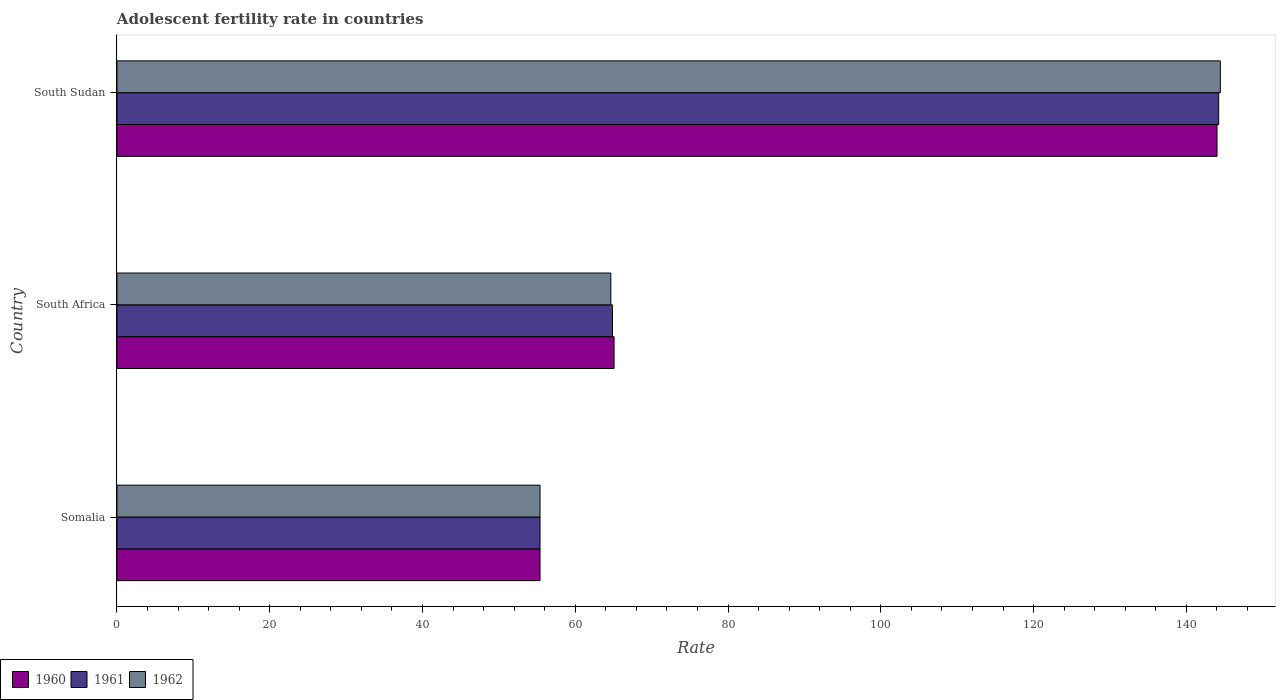How many different coloured bars are there?
Provide a short and direct response. 3. How many groups of bars are there?
Give a very brief answer. 3. Are the number of bars per tick equal to the number of legend labels?
Offer a terse response. Yes. Are the number of bars on each tick of the Y-axis equal?
Provide a succinct answer. Yes. How many bars are there on the 1st tick from the top?
Keep it short and to the point. 3. What is the label of the 1st group of bars from the top?
Offer a very short reply. South Sudan. What is the adolescent fertility rate in 1960 in South Sudan?
Give a very brief answer. 144.02. Across all countries, what is the maximum adolescent fertility rate in 1960?
Provide a succinct answer. 144.02. Across all countries, what is the minimum adolescent fertility rate in 1960?
Your answer should be compact. 55.39. In which country was the adolescent fertility rate in 1961 maximum?
Give a very brief answer. South Sudan. In which country was the adolescent fertility rate in 1961 minimum?
Ensure brevity in your answer.  Somalia. What is the total adolescent fertility rate in 1961 in the graph?
Give a very brief answer. 264.5. What is the difference between the adolescent fertility rate in 1960 in Somalia and that in South Africa?
Provide a short and direct response. -9.7. What is the difference between the adolescent fertility rate in 1960 in South Africa and the adolescent fertility rate in 1961 in South Sudan?
Provide a succinct answer. -79.15. What is the average adolescent fertility rate in 1961 per country?
Make the answer very short. 88.17. What is the difference between the adolescent fertility rate in 1960 and adolescent fertility rate in 1961 in Somalia?
Your response must be concise. 0. In how many countries, is the adolescent fertility rate in 1962 greater than 4 ?
Ensure brevity in your answer.  3. What is the ratio of the adolescent fertility rate in 1961 in Somalia to that in South Africa?
Your response must be concise. 0.85. Is the adolescent fertility rate in 1960 in Somalia less than that in South Sudan?
Ensure brevity in your answer.  Yes. What is the difference between the highest and the second highest adolescent fertility rate in 1961?
Your response must be concise. 79.36. What is the difference between the highest and the lowest adolescent fertility rate in 1962?
Keep it short and to the point. 89.06. Is the sum of the adolescent fertility rate in 1962 in Somalia and South Sudan greater than the maximum adolescent fertility rate in 1961 across all countries?
Offer a very short reply. Yes. How many countries are there in the graph?
Offer a terse response. 3. Are the values on the major ticks of X-axis written in scientific E-notation?
Offer a terse response. No. Does the graph contain grids?
Your answer should be very brief. No. What is the title of the graph?
Provide a short and direct response. Adolescent fertility rate in countries. What is the label or title of the X-axis?
Your answer should be compact. Rate. What is the label or title of the Y-axis?
Ensure brevity in your answer.  Country. What is the Rate of 1960 in Somalia?
Keep it short and to the point. 55.39. What is the Rate of 1961 in Somalia?
Make the answer very short. 55.39. What is the Rate of 1962 in Somalia?
Keep it short and to the point. 55.39. What is the Rate in 1960 in South Africa?
Provide a short and direct response. 65.08. What is the Rate in 1961 in South Africa?
Make the answer very short. 64.87. What is the Rate of 1962 in South Africa?
Make the answer very short. 64.66. What is the Rate in 1960 in South Sudan?
Your answer should be compact. 144.02. What is the Rate in 1961 in South Sudan?
Ensure brevity in your answer.  144.24. What is the Rate of 1962 in South Sudan?
Your answer should be very brief. 144.45. Across all countries, what is the maximum Rate of 1960?
Give a very brief answer. 144.02. Across all countries, what is the maximum Rate in 1961?
Your answer should be compact. 144.24. Across all countries, what is the maximum Rate in 1962?
Offer a very short reply. 144.45. Across all countries, what is the minimum Rate of 1960?
Offer a very short reply. 55.39. Across all countries, what is the minimum Rate in 1961?
Your response must be concise. 55.39. Across all countries, what is the minimum Rate of 1962?
Provide a short and direct response. 55.39. What is the total Rate of 1960 in the graph?
Make the answer very short. 264.5. What is the total Rate of 1961 in the graph?
Ensure brevity in your answer.  264.5. What is the total Rate of 1962 in the graph?
Your response must be concise. 264.5. What is the difference between the Rate of 1960 in Somalia and that in South Africa?
Your response must be concise. -9.7. What is the difference between the Rate in 1961 in Somalia and that in South Africa?
Provide a succinct answer. -9.48. What is the difference between the Rate of 1962 in Somalia and that in South Africa?
Offer a terse response. -9.27. What is the difference between the Rate of 1960 in Somalia and that in South Sudan?
Give a very brief answer. -88.63. What is the difference between the Rate in 1961 in Somalia and that in South Sudan?
Make the answer very short. -88.85. What is the difference between the Rate in 1962 in Somalia and that in South Sudan?
Provide a succinct answer. -89.06. What is the difference between the Rate in 1960 in South Africa and that in South Sudan?
Make the answer very short. -78.94. What is the difference between the Rate in 1961 in South Africa and that in South Sudan?
Keep it short and to the point. -79.36. What is the difference between the Rate of 1962 in South Africa and that in South Sudan?
Your response must be concise. -79.79. What is the difference between the Rate in 1960 in Somalia and the Rate in 1961 in South Africa?
Your answer should be compact. -9.48. What is the difference between the Rate in 1960 in Somalia and the Rate in 1962 in South Africa?
Provide a short and direct response. -9.27. What is the difference between the Rate in 1961 in Somalia and the Rate in 1962 in South Africa?
Ensure brevity in your answer.  -9.27. What is the difference between the Rate of 1960 in Somalia and the Rate of 1961 in South Sudan?
Give a very brief answer. -88.85. What is the difference between the Rate of 1960 in Somalia and the Rate of 1962 in South Sudan?
Your response must be concise. -89.06. What is the difference between the Rate in 1961 in Somalia and the Rate in 1962 in South Sudan?
Your answer should be very brief. -89.06. What is the difference between the Rate in 1960 in South Africa and the Rate in 1961 in South Sudan?
Your response must be concise. -79.15. What is the difference between the Rate of 1960 in South Africa and the Rate of 1962 in South Sudan?
Your response must be concise. -79.37. What is the difference between the Rate in 1961 in South Africa and the Rate in 1962 in South Sudan?
Ensure brevity in your answer.  -79.58. What is the average Rate of 1960 per country?
Keep it short and to the point. 88.17. What is the average Rate in 1961 per country?
Your answer should be compact. 88.17. What is the average Rate in 1962 per country?
Make the answer very short. 88.17. What is the difference between the Rate in 1960 and Rate in 1962 in Somalia?
Offer a terse response. 0. What is the difference between the Rate in 1960 and Rate in 1961 in South Africa?
Offer a very short reply. 0.21. What is the difference between the Rate of 1960 and Rate of 1962 in South Africa?
Make the answer very short. 0.42. What is the difference between the Rate in 1961 and Rate in 1962 in South Africa?
Your answer should be very brief. 0.21. What is the difference between the Rate of 1960 and Rate of 1961 in South Sudan?
Keep it short and to the point. -0.21. What is the difference between the Rate of 1960 and Rate of 1962 in South Sudan?
Provide a short and direct response. -0.43. What is the difference between the Rate of 1961 and Rate of 1962 in South Sudan?
Your response must be concise. -0.21. What is the ratio of the Rate of 1960 in Somalia to that in South Africa?
Give a very brief answer. 0.85. What is the ratio of the Rate of 1961 in Somalia to that in South Africa?
Offer a terse response. 0.85. What is the ratio of the Rate in 1962 in Somalia to that in South Africa?
Your response must be concise. 0.86. What is the ratio of the Rate in 1960 in Somalia to that in South Sudan?
Provide a short and direct response. 0.38. What is the ratio of the Rate in 1961 in Somalia to that in South Sudan?
Offer a terse response. 0.38. What is the ratio of the Rate of 1962 in Somalia to that in South Sudan?
Ensure brevity in your answer.  0.38. What is the ratio of the Rate of 1960 in South Africa to that in South Sudan?
Provide a short and direct response. 0.45. What is the ratio of the Rate of 1961 in South Africa to that in South Sudan?
Give a very brief answer. 0.45. What is the ratio of the Rate in 1962 in South Africa to that in South Sudan?
Your answer should be compact. 0.45. What is the difference between the highest and the second highest Rate in 1960?
Make the answer very short. 78.94. What is the difference between the highest and the second highest Rate in 1961?
Provide a succinct answer. 79.36. What is the difference between the highest and the second highest Rate of 1962?
Ensure brevity in your answer.  79.79. What is the difference between the highest and the lowest Rate in 1960?
Your answer should be compact. 88.63. What is the difference between the highest and the lowest Rate in 1961?
Provide a succinct answer. 88.85. What is the difference between the highest and the lowest Rate of 1962?
Ensure brevity in your answer.  89.06. 